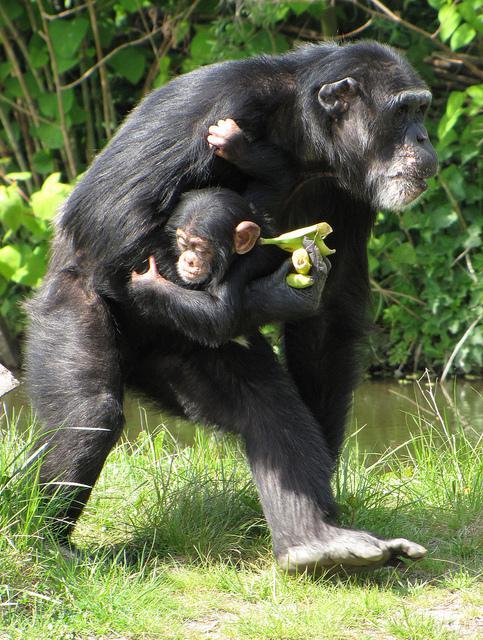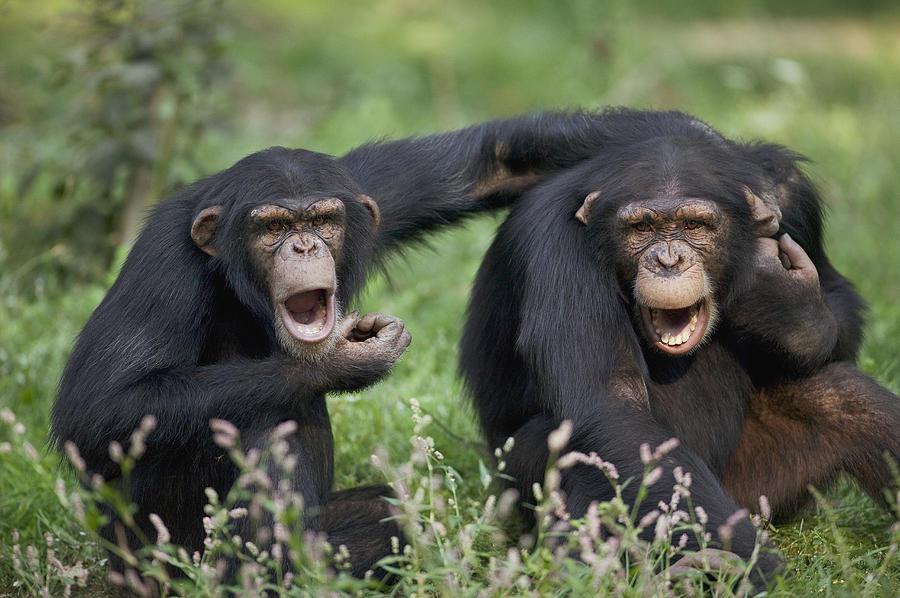The first image is the image on the left, the second image is the image on the right. Evaluate the accuracy of this statement regarding the images: "The primate in the image on the right is holding onto a large branch.". Is it true? Answer yes or no. No. The first image is the image on the left, the second image is the image on the right. For the images displayed, is the sentence "An image shows one non-sleeping chimp, which is perched on a wooden object." factually correct? Answer yes or no. No. 